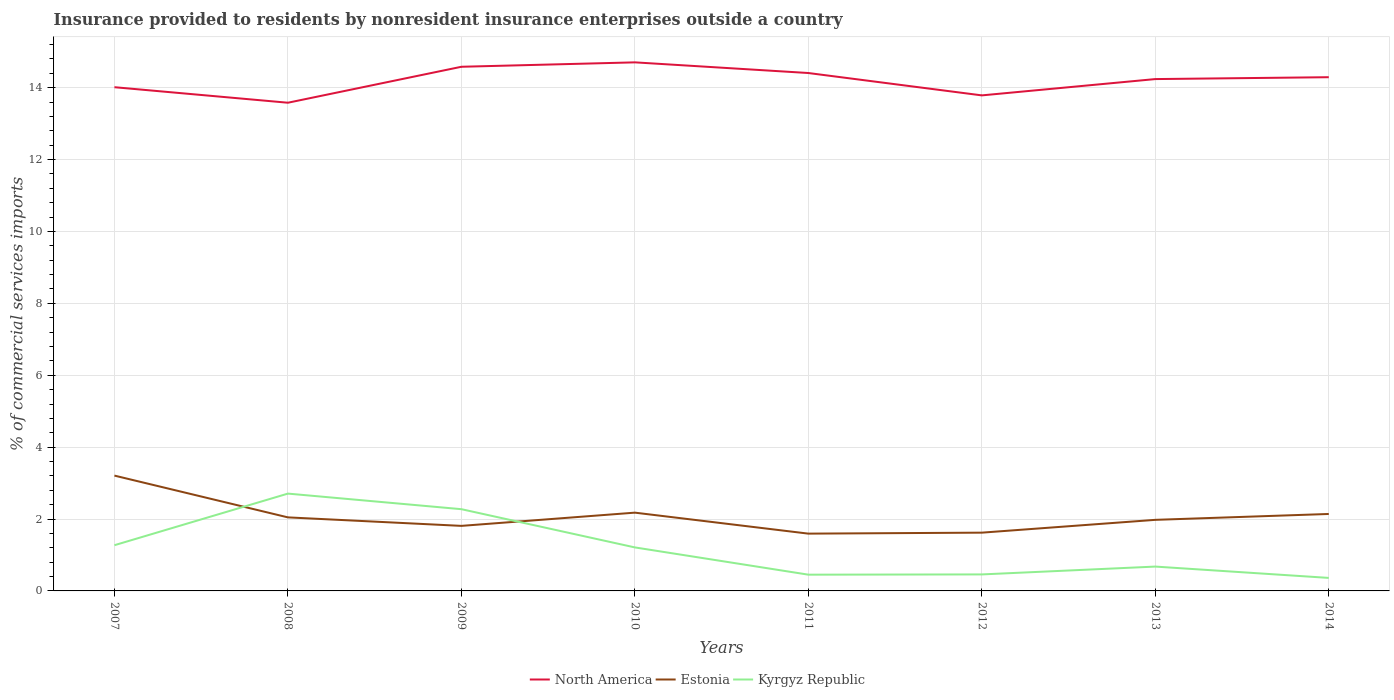Is the number of lines equal to the number of legend labels?
Your answer should be compact. Yes. Across all years, what is the maximum Insurance provided to residents in Estonia?
Provide a succinct answer. 1.59. What is the total Insurance provided to residents in North America in the graph?
Ensure brevity in your answer.  -0.12. What is the difference between the highest and the second highest Insurance provided to residents in North America?
Your answer should be compact. 1.12. Is the Insurance provided to residents in North America strictly greater than the Insurance provided to residents in Kyrgyz Republic over the years?
Offer a very short reply. No. How many years are there in the graph?
Give a very brief answer. 8. Does the graph contain any zero values?
Provide a short and direct response. No. How many legend labels are there?
Give a very brief answer. 3. How are the legend labels stacked?
Offer a very short reply. Horizontal. What is the title of the graph?
Make the answer very short. Insurance provided to residents by nonresident insurance enterprises outside a country. Does "Latin America(all income levels)" appear as one of the legend labels in the graph?
Give a very brief answer. No. What is the label or title of the Y-axis?
Provide a succinct answer. % of commercial services imports. What is the % of commercial services imports of North America in 2007?
Offer a very short reply. 14.01. What is the % of commercial services imports in Estonia in 2007?
Offer a very short reply. 3.21. What is the % of commercial services imports in Kyrgyz Republic in 2007?
Make the answer very short. 1.27. What is the % of commercial services imports of North America in 2008?
Provide a short and direct response. 13.58. What is the % of commercial services imports of Estonia in 2008?
Make the answer very short. 2.05. What is the % of commercial services imports of Kyrgyz Republic in 2008?
Offer a very short reply. 2.71. What is the % of commercial services imports in North America in 2009?
Your answer should be very brief. 14.58. What is the % of commercial services imports of Estonia in 2009?
Your answer should be very brief. 1.81. What is the % of commercial services imports in Kyrgyz Republic in 2009?
Make the answer very short. 2.27. What is the % of commercial services imports of North America in 2010?
Keep it short and to the point. 14.71. What is the % of commercial services imports in Estonia in 2010?
Keep it short and to the point. 2.18. What is the % of commercial services imports in Kyrgyz Republic in 2010?
Your answer should be very brief. 1.21. What is the % of commercial services imports of North America in 2011?
Provide a short and direct response. 14.41. What is the % of commercial services imports in Estonia in 2011?
Make the answer very short. 1.59. What is the % of commercial services imports of Kyrgyz Republic in 2011?
Keep it short and to the point. 0.45. What is the % of commercial services imports of North America in 2012?
Give a very brief answer. 13.79. What is the % of commercial services imports of Estonia in 2012?
Your answer should be very brief. 1.62. What is the % of commercial services imports of Kyrgyz Republic in 2012?
Provide a short and direct response. 0.46. What is the % of commercial services imports of North America in 2013?
Ensure brevity in your answer.  14.24. What is the % of commercial services imports of Estonia in 2013?
Offer a terse response. 1.98. What is the % of commercial services imports of Kyrgyz Republic in 2013?
Keep it short and to the point. 0.68. What is the % of commercial services imports in North America in 2014?
Ensure brevity in your answer.  14.29. What is the % of commercial services imports in Estonia in 2014?
Offer a very short reply. 2.14. What is the % of commercial services imports of Kyrgyz Republic in 2014?
Keep it short and to the point. 0.36. Across all years, what is the maximum % of commercial services imports in North America?
Give a very brief answer. 14.71. Across all years, what is the maximum % of commercial services imports of Estonia?
Provide a short and direct response. 3.21. Across all years, what is the maximum % of commercial services imports of Kyrgyz Republic?
Provide a succinct answer. 2.71. Across all years, what is the minimum % of commercial services imports of North America?
Keep it short and to the point. 13.58. Across all years, what is the minimum % of commercial services imports of Estonia?
Keep it short and to the point. 1.59. Across all years, what is the minimum % of commercial services imports of Kyrgyz Republic?
Give a very brief answer. 0.36. What is the total % of commercial services imports in North America in the graph?
Your response must be concise. 113.61. What is the total % of commercial services imports in Estonia in the graph?
Give a very brief answer. 16.57. What is the total % of commercial services imports in Kyrgyz Republic in the graph?
Give a very brief answer. 9.41. What is the difference between the % of commercial services imports of North America in 2007 and that in 2008?
Make the answer very short. 0.43. What is the difference between the % of commercial services imports in Estonia in 2007 and that in 2008?
Offer a very short reply. 1.16. What is the difference between the % of commercial services imports in Kyrgyz Republic in 2007 and that in 2008?
Offer a very short reply. -1.44. What is the difference between the % of commercial services imports of North America in 2007 and that in 2009?
Ensure brevity in your answer.  -0.57. What is the difference between the % of commercial services imports in Estonia in 2007 and that in 2009?
Ensure brevity in your answer.  1.4. What is the difference between the % of commercial services imports in Kyrgyz Republic in 2007 and that in 2009?
Provide a short and direct response. -1. What is the difference between the % of commercial services imports in North America in 2007 and that in 2010?
Your answer should be compact. -0.69. What is the difference between the % of commercial services imports of Estonia in 2007 and that in 2010?
Give a very brief answer. 1.03. What is the difference between the % of commercial services imports in Kyrgyz Republic in 2007 and that in 2010?
Provide a short and direct response. 0.06. What is the difference between the % of commercial services imports of North America in 2007 and that in 2011?
Your answer should be very brief. -0.39. What is the difference between the % of commercial services imports in Estonia in 2007 and that in 2011?
Give a very brief answer. 1.61. What is the difference between the % of commercial services imports in Kyrgyz Republic in 2007 and that in 2011?
Make the answer very short. 0.82. What is the difference between the % of commercial services imports of North America in 2007 and that in 2012?
Offer a very short reply. 0.23. What is the difference between the % of commercial services imports of Estonia in 2007 and that in 2012?
Provide a short and direct response. 1.59. What is the difference between the % of commercial services imports in Kyrgyz Republic in 2007 and that in 2012?
Ensure brevity in your answer.  0.81. What is the difference between the % of commercial services imports in North America in 2007 and that in 2013?
Your answer should be compact. -0.23. What is the difference between the % of commercial services imports in Estonia in 2007 and that in 2013?
Offer a very short reply. 1.23. What is the difference between the % of commercial services imports of Kyrgyz Republic in 2007 and that in 2013?
Your response must be concise. 0.59. What is the difference between the % of commercial services imports in North America in 2007 and that in 2014?
Keep it short and to the point. -0.28. What is the difference between the % of commercial services imports in Estonia in 2007 and that in 2014?
Provide a short and direct response. 1.07. What is the difference between the % of commercial services imports of Kyrgyz Republic in 2007 and that in 2014?
Offer a very short reply. 0.91. What is the difference between the % of commercial services imports of North America in 2008 and that in 2009?
Offer a terse response. -1. What is the difference between the % of commercial services imports in Estonia in 2008 and that in 2009?
Your answer should be compact. 0.24. What is the difference between the % of commercial services imports of Kyrgyz Republic in 2008 and that in 2009?
Make the answer very short. 0.43. What is the difference between the % of commercial services imports in North America in 2008 and that in 2010?
Ensure brevity in your answer.  -1.12. What is the difference between the % of commercial services imports in Estonia in 2008 and that in 2010?
Your response must be concise. -0.13. What is the difference between the % of commercial services imports in Kyrgyz Republic in 2008 and that in 2010?
Keep it short and to the point. 1.5. What is the difference between the % of commercial services imports in North America in 2008 and that in 2011?
Ensure brevity in your answer.  -0.83. What is the difference between the % of commercial services imports of Estonia in 2008 and that in 2011?
Ensure brevity in your answer.  0.45. What is the difference between the % of commercial services imports in Kyrgyz Republic in 2008 and that in 2011?
Offer a very short reply. 2.26. What is the difference between the % of commercial services imports of North America in 2008 and that in 2012?
Your response must be concise. -0.2. What is the difference between the % of commercial services imports of Estonia in 2008 and that in 2012?
Make the answer very short. 0.42. What is the difference between the % of commercial services imports of Kyrgyz Republic in 2008 and that in 2012?
Your answer should be very brief. 2.25. What is the difference between the % of commercial services imports of North America in 2008 and that in 2013?
Keep it short and to the point. -0.66. What is the difference between the % of commercial services imports in Estonia in 2008 and that in 2013?
Your answer should be very brief. 0.07. What is the difference between the % of commercial services imports of Kyrgyz Republic in 2008 and that in 2013?
Your response must be concise. 2.03. What is the difference between the % of commercial services imports in North America in 2008 and that in 2014?
Provide a succinct answer. -0.71. What is the difference between the % of commercial services imports of Estonia in 2008 and that in 2014?
Offer a very short reply. -0.09. What is the difference between the % of commercial services imports in Kyrgyz Republic in 2008 and that in 2014?
Provide a short and direct response. 2.35. What is the difference between the % of commercial services imports in North America in 2009 and that in 2010?
Provide a short and direct response. -0.12. What is the difference between the % of commercial services imports in Estonia in 2009 and that in 2010?
Provide a short and direct response. -0.37. What is the difference between the % of commercial services imports in Kyrgyz Republic in 2009 and that in 2010?
Your answer should be compact. 1.06. What is the difference between the % of commercial services imports in North America in 2009 and that in 2011?
Make the answer very short. 0.17. What is the difference between the % of commercial services imports in Estonia in 2009 and that in 2011?
Provide a succinct answer. 0.22. What is the difference between the % of commercial services imports of Kyrgyz Republic in 2009 and that in 2011?
Make the answer very short. 1.82. What is the difference between the % of commercial services imports in North America in 2009 and that in 2012?
Keep it short and to the point. 0.8. What is the difference between the % of commercial services imports of Estonia in 2009 and that in 2012?
Offer a very short reply. 0.19. What is the difference between the % of commercial services imports in Kyrgyz Republic in 2009 and that in 2012?
Your response must be concise. 1.81. What is the difference between the % of commercial services imports of North America in 2009 and that in 2013?
Ensure brevity in your answer.  0.34. What is the difference between the % of commercial services imports of Estonia in 2009 and that in 2013?
Your answer should be very brief. -0.17. What is the difference between the % of commercial services imports in Kyrgyz Republic in 2009 and that in 2013?
Your answer should be very brief. 1.6. What is the difference between the % of commercial services imports of North America in 2009 and that in 2014?
Offer a terse response. 0.29. What is the difference between the % of commercial services imports of Estonia in 2009 and that in 2014?
Your answer should be very brief. -0.33. What is the difference between the % of commercial services imports of Kyrgyz Republic in 2009 and that in 2014?
Your answer should be compact. 1.91. What is the difference between the % of commercial services imports in North America in 2010 and that in 2011?
Provide a succinct answer. 0.3. What is the difference between the % of commercial services imports of Estonia in 2010 and that in 2011?
Ensure brevity in your answer.  0.58. What is the difference between the % of commercial services imports of Kyrgyz Republic in 2010 and that in 2011?
Provide a succinct answer. 0.76. What is the difference between the % of commercial services imports of North America in 2010 and that in 2012?
Make the answer very short. 0.92. What is the difference between the % of commercial services imports of Estonia in 2010 and that in 2012?
Give a very brief answer. 0.56. What is the difference between the % of commercial services imports of Kyrgyz Republic in 2010 and that in 2012?
Offer a very short reply. 0.75. What is the difference between the % of commercial services imports in North America in 2010 and that in 2013?
Your answer should be compact. 0.47. What is the difference between the % of commercial services imports in Estonia in 2010 and that in 2013?
Your answer should be very brief. 0.2. What is the difference between the % of commercial services imports of Kyrgyz Republic in 2010 and that in 2013?
Provide a succinct answer. 0.53. What is the difference between the % of commercial services imports of North America in 2010 and that in 2014?
Make the answer very short. 0.41. What is the difference between the % of commercial services imports of Estonia in 2010 and that in 2014?
Ensure brevity in your answer.  0.04. What is the difference between the % of commercial services imports of Kyrgyz Republic in 2010 and that in 2014?
Your answer should be very brief. 0.85. What is the difference between the % of commercial services imports in North America in 2011 and that in 2012?
Provide a succinct answer. 0.62. What is the difference between the % of commercial services imports of Estonia in 2011 and that in 2012?
Your answer should be compact. -0.03. What is the difference between the % of commercial services imports in Kyrgyz Republic in 2011 and that in 2012?
Ensure brevity in your answer.  -0.01. What is the difference between the % of commercial services imports in North America in 2011 and that in 2013?
Keep it short and to the point. 0.17. What is the difference between the % of commercial services imports in Estonia in 2011 and that in 2013?
Ensure brevity in your answer.  -0.38. What is the difference between the % of commercial services imports in Kyrgyz Republic in 2011 and that in 2013?
Provide a short and direct response. -0.22. What is the difference between the % of commercial services imports in North America in 2011 and that in 2014?
Offer a terse response. 0.12. What is the difference between the % of commercial services imports in Estonia in 2011 and that in 2014?
Make the answer very short. -0.55. What is the difference between the % of commercial services imports in Kyrgyz Republic in 2011 and that in 2014?
Ensure brevity in your answer.  0.09. What is the difference between the % of commercial services imports in North America in 2012 and that in 2013?
Your answer should be compact. -0.45. What is the difference between the % of commercial services imports in Estonia in 2012 and that in 2013?
Make the answer very short. -0.36. What is the difference between the % of commercial services imports in Kyrgyz Republic in 2012 and that in 2013?
Your answer should be very brief. -0.22. What is the difference between the % of commercial services imports in North America in 2012 and that in 2014?
Offer a terse response. -0.51. What is the difference between the % of commercial services imports in Estonia in 2012 and that in 2014?
Ensure brevity in your answer.  -0.52. What is the difference between the % of commercial services imports of Kyrgyz Republic in 2012 and that in 2014?
Your answer should be very brief. 0.1. What is the difference between the % of commercial services imports in North America in 2013 and that in 2014?
Ensure brevity in your answer.  -0.05. What is the difference between the % of commercial services imports in Estonia in 2013 and that in 2014?
Offer a terse response. -0.16. What is the difference between the % of commercial services imports in Kyrgyz Republic in 2013 and that in 2014?
Keep it short and to the point. 0.32. What is the difference between the % of commercial services imports in North America in 2007 and the % of commercial services imports in Estonia in 2008?
Offer a very short reply. 11.97. What is the difference between the % of commercial services imports of North America in 2007 and the % of commercial services imports of Kyrgyz Republic in 2008?
Give a very brief answer. 11.31. What is the difference between the % of commercial services imports in Estonia in 2007 and the % of commercial services imports in Kyrgyz Republic in 2008?
Ensure brevity in your answer.  0.5. What is the difference between the % of commercial services imports of North America in 2007 and the % of commercial services imports of Estonia in 2009?
Give a very brief answer. 12.2. What is the difference between the % of commercial services imports in North America in 2007 and the % of commercial services imports in Kyrgyz Republic in 2009?
Your answer should be compact. 11.74. What is the difference between the % of commercial services imports in Estonia in 2007 and the % of commercial services imports in Kyrgyz Republic in 2009?
Keep it short and to the point. 0.93. What is the difference between the % of commercial services imports in North America in 2007 and the % of commercial services imports in Estonia in 2010?
Provide a succinct answer. 11.84. What is the difference between the % of commercial services imports of North America in 2007 and the % of commercial services imports of Kyrgyz Republic in 2010?
Make the answer very short. 12.8. What is the difference between the % of commercial services imports of Estonia in 2007 and the % of commercial services imports of Kyrgyz Republic in 2010?
Provide a succinct answer. 2. What is the difference between the % of commercial services imports in North America in 2007 and the % of commercial services imports in Estonia in 2011?
Keep it short and to the point. 12.42. What is the difference between the % of commercial services imports of North America in 2007 and the % of commercial services imports of Kyrgyz Republic in 2011?
Provide a short and direct response. 13.56. What is the difference between the % of commercial services imports of Estonia in 2007 and the % of commercial services imports of Kyrgyz Republic in 2011?
Provide a short and direct response. 2.76. What is the difference between the % of commercial services imports in North America in 2007 and the % of commercial services imports in Estonia in 2012?
Provide a short and direct response. 12.39. What is the difference between the % of commercial services imports of North America in 2007 and the % of commercial services imports of Kyrgyz Republic in 2012?
Provide a short and direct response. 13.55. What is the difference between the % of commercial services imports in Estonia in 2007 and the % of commercial services imports in Kyrgyz Republic in 2012?
Give a very brief answer. 2.75. What is the difference between the % of commercial services imports in North America in 2007 and the % of commercial services imports in Estonia in 2013?
Offer a terse response. 12.04. What is the difference between the % of commercial services imports of North America in 2007 and the % of commercial services imports of Kyrgyz Republic in 2013?
Your answer should be very brief. 13.34. What is the difference between the % of commercial services imports of Estonia in 2007 and the % of commercial services imports of Kyrgyz Republic in 2013?
Provide a succinct answer. 2.53. What is the difference between the % of commercial services imports in North America in 2007 and the % of commercial services imports in Estonia in 2014?
Make the answer very short. 11.87. What is the difference between the % of commercial services imports in North America in 2007 and the % of commercial services imports in Kyrgyz Republic in 2014?
Your answer should be compact. 13.65. What is the difference between the % of commercial services imports of Estonia in 2007 and the % of commercial services imports of Kyrgyz Republic in 2014?
Your answer should be compact. 2.85. What is the difference between the % of commercial services imports in North America in 2008 and the % of commercial services imports in Estonia in 2009?
Your answer should be very brief. 11.77. What is the difference between the % of commercial services imports in North America in 2008 and the % of commercial services imports in Kyrgyz Republic in 2009?
Offer a terse response. 11.31. What is the difference between the % of commercial services imports of Estonia in 2008 and the % of commercial services imports of Kyrgyz Republic in 2009?
Your response must be concise. -0.23. What is the difference between the % of commercial services imports in North America in 2008 and the % of commercial services imports in Estonia in 2010?
Provide a short and direct response. 11.4. What is the difference between the % of commercial services imports of North America in 2008 and the % of commercial services imports of Kyrgyz Republic in 2010?
Your response must be concise. 12.37. What is the difference between the % of commercial services imports of Estonia in 2008 and the % of commercial services imports of Kyrgyz Republic in 2010?
Offer a terse response. 0.84. What is the difference between the % of commercial services imports in North America in 2008 and the % of commercial services imports in Estonia in 2011?
Provide a succinct answer. 11.99. What is the difference between the % of commercial services imports in North America in 2008 and the % of commercial services imports in Kyrgyz Republic in 2011?
Provide a succinct answer. 13.13. What is the difference between the % of commercial services imports of Estonia in 2008 and the % of commercial services imports of Kyrgyz Republic in 2011?
Your answer should be compact. 1.59. What is the difference between the % of commercial services imports of North America in 2008 and the % of commercial services imports of Estonia in 2012?
Your response must be concise. 11.96. What is the difference between the % of commercial services imports in North America in 2008 and the % of commercial services imports in Kyrgyz Republic in 2012?
Ensure brevity in your answer.  13.12. What is the difference between the % of commercial services imports in Estonia in 2008 and the % of commercial services imports in Kyrgyz Republic in 2012?
Your answer should be very brief. 1.59. What is the difference between the % of commercial services imports of North America in 2008 and the % of commercial services imports of Estonia in 2013?
Your answer should be very brief. 11.6. What is the difference between the % of commercial services imports in North America in 2008 and the % of commercial services imports in Kyrgyz Republic in 2013?
Provide a succinct answer. 12.9. What is the difference between the % of commercial services imports in Estonia in 2008 and the % of commercial services imports in Kyrgyz Republic in 2013?
Your response must be concise. 1.37. What is the difference between the % of commercial services imports in North America in 2008 and the % of commercial services imports in Estonia in 2014?
Your answer should be very brief. 11.44. What is the difference between the % of commercial services imports in North America in 2008 and the % of commercial services imports in Kyrgyz Republic in 2014?
Offer a very short reply. 13.22. What is the difference between the % of commercial services imports of Estonia in 2008 and the % of commercial services imports of Kyrgyz Republic in 2014?
Offer a terse response. 1.68. What is the difference between the % of commercial services imports of North America in 2009 and the % of commercial services imports of Estonia in 2010?
Your answer should be compact. 12.4. What is the difference between the % of commercial services imports of North America in 2009 and the % of commercial services imports of Kyrgyz Republic in 2010?
Provide a succinct answer. 13.37. What is the difference between the % of commercial services imports of Estonia in 2009 and the % of commercial services imports of Kyrgyz Republic in 2010?
Provide a short and direct response. 0.6. What is the difference between the % of commercial services imports in North America in 2009 and the % of commercial services imports in Estonia in 2011?
Ensure brevity in your answer.  12.99. What is the difference between the % of commercial services imports of North America in 2009 and the % of commercial services imports of Kyrgyz Republic in 2011?
Your answer should be very brief. 14.13. What is the difference between the % of commercial services imports in Estonia in 2009 and the % of commercial services imports in Kyrgyz Republic in 2011?
Offer a very short reply. 1.36. What is the difference between the % of commercial services imports in North America in 2009 and the % of commercial services imports in Estonia in 2012?
Your answer should be very brief. 12.96. What is the difference between the % of commercial services imports in North America in 2009 and the % of commercial services imports in Kyrgyz Republic in 2012?
Offer a terse response. 14.12. What is the difference between the % of commercial services imports of Estonia in 2009 and the % of commercial services imports of Kyrgyz Republic in 2012?
Make the answer very short. 1.35. What is the difference between the % of commercial services imports of North America in 2009 and the % of commercial services imports of Estonia in 2013?
Keep it short and to the point. 12.6. What is the difference between the % of commercial services imports of North America in 2009 and the % of commercial services imports of Kyrgyz Republic in 2013?
Your answer should be compact. 13.91. What is the difference between the % of commercial services imports in Estonia in 2009 and the % of commercial services imports in Kyrgyz Republic in 2013?
Ensure brevity in your answer.  1.13. What is the difference between the % of commercial services imports of North America in 2009 and the % of commercial services imports of Estonia in 2014?
Your answer should be compact. 12.44. What is the difference between the % of commercial services imports of North America in 2009 and the % of commercial services imports of Kyrgyz Republic in 2014?
Your answer should be very brief. 14.22. What is the difference between the % of commercial services imports of Estonia in 2009 and the % of commercial services imports of Kyrgyz Republic in 2014?
Provide a short and direct response. 1.45. What is the difference between the % of commercial services imports in North America in 2010 and the % of commercial services imports in Estonia in 2011?
Your answer should be compact. 13.11. What is the difference between the % of commercial services imports in North America in 2010 and the % of commercial services imports in Kyrgyz Republic in 2011?
Provide a short and direct response. 14.25. What is the difference between the % of commercial services imports in Estonia in 2010 and the % of commercial services imports in Kyrgyz Republic in 2011?
Your answer should be compact. 1.73. What is the difference between the % of commercial services imports of North America in 2010 and the % of commercial services imports of Estonia in 2012?
Your response must be concise. 13.08. What is the difference between the % of commercial services imports of North America in 2010 and the % of commercial services imports of Kyrgyz Republic in 2012?
Give a very brief answer. 14.25. What is the difference between the % of commercial services imports in Estonia in 2010 and the % of commercial services imports in Kyrgyz Republic in 2012?
Provide a short and direct response. 1.72. What is the difference between the % of commercial services imports in North America in 2010 and the % of commercial services imports in Estonia in 2013?
Your response must be concise. 12.73. What is the difference between the % of commercial services imports in North America in 2010 and the % of commercial services imports in Kyrgyz Republic in 2013?
Provide a succinct answer. 14.03. What is the difference between the % of commercial services imports of Estonia in 2010 and the % of commercial services imports of Kyrgyz Republic in 2013?
Your answer should be very brief. 1.5. What is the difference between the % of commercial services imports in North America in 2010 and the % of commercial services imports in Estonia in 2014?
Your answer should be very brief. 12.56. What is the difference between the % of commercial services imports of North America in 2010 and the % of commercial services imports of Kyrgyz Republic in 2014?
Offer a very short reply. 14.34. What is the difference between the % of commercial services imports of Estonia in 2010 and the % of commercial services imports of Kyrgyz Republic in 2014?
Provide a short and direct response. 1.82. What is the difference between the % of commercial services imports of North America in 2011 and the % of commercial services imports of Estonia in 2012?
Your answer should be very brief. 12.79. What is the difference between the % of commercial services imports in North America in 2011 and the % of commercial services imports in Kyrgyz Republic in 2012?
Offer a very short reply. 13.95. What is the difference between the % of commercial services imports in Estonia in 2011 and the % of commercial services imports in Kyrgyz Republic in 2012?
Your answer should be very brief. 1.13. What is the difference between the % of commercial services imports of North America in 2011 and the % of commercial services imports of Estonia in 2013?
Keep it short and to the point. 12.43. What is the difference between the % of commercial services imports in North America in 2011 and the % of commercial services imports in Kyrgyz Republic in 2013?
Ensure brevity in your answer.  13.73. What is the difference between the % of commercial services imports of Estonia in 2011 and the % of commercial services imports of Kyrgyz Republic in 2013?
Your answer should be very brief. 0.92. What is the difference between the % of commercial services imports of North America in 2011 and the % of commercial services imports of Estonia in 2014?
Your answer should be compact. 12.27. What is the difference between the % of commercial services imports of North America in 2011 and the % of commercial services imports of Kyrgyz Republic in 2014?
Provide a short and direct response. 14.05. What is the difference between the % of commercial services imports of Estonia in 2011 and the % of commercial services imports of Kyrgyz Republic in 2014?
Your answer should be very brief. 1.23. What is the difference between the % of commercial services imports of North America in 2012 and the % of commercial services imports of Estonia in 2013?
Your answer should be compact. 11.81. What is the difference between the % of commercial services imports of North America in 2012 and the % of commercial services imports of Kyrgyz Republic in 2013?
Your answer should be compact. 13.11. What is the difference between the % of commercial services imports of Estonia in 2012 and the % of commercial services imports of Kyrgyz Republic in 2013?
Give a very brief answer. 0.94. What is the difference between the % of commercial services imports in North America in 2012 and the % of commercial services imports in Estonia in 2014?
Ensure brevity in your answer.  11.65. What is the difference between the % of commercial services imports in North America in 2012 and the % of commercial services imports in Kyrgyz Republic in 2014?
Give a very brief answer. 13.42. What is the difference between the % of commercial services imports in Estonia in 2012 and the % of commercial services imports in Kyrgyz Republic in 2014?
Make the answer very short. 1.26. What is the difference between the % of commercial services imports in North America in 2013 and the % of commercial services imports in Estonia in 2014?
Your answer should be very brief. 12.1. What is the difference between the % of commercial services imports in North America in 2013 and the % of commercial services imports in Kyrgyz Republic in 2014?
Offer a very short reply. 13.88. What is the difference between the % of commercial services imports of Estonia in 2013 and the % of commercial services imports of Kyrgyz Republic in 2014?
Your response must be concise. 1.62. What is the average % of commercial services imports of North America per year?
Provide a short and direct response. 14.2. What is the average % of commercial services imports in Estonia per year?
Provide a succinct answer. 2.07. What is the average % of commercial services imports of Kyrgyz Republic per year?
Your answer should be very brief. 1.18. In the year 2007, what is the difference between the % of commercial services imports of North America and % of commercial services imports of Estonia?
Give a very brief answer. 10.81. In the year 2007, what is the difference between the % of commercial services imports of North America and % of commercial services imports of Kyrgyz Republic?
Ensure brevity in your answer.  12.74. In the year 2007, what is the difference between the % of commercial services imports in Estonia and % of commercial services imports in Kyrgyz Republic?
Make the answer very short. 1.94. In the year 2008, what is the difference between the % of commercial services imports of North America and % of commercial services imports of Estonia?
Your response must be concise. 11.54. In the year 2008, what is the difference between the % of commercial services imports of North America and % of commercial services imports of Kyrgyz Republic?
Provide a short and direct response. 10.87. In the year 2008, what is the difference between the % of commercial services imports in Estonia and % of commercial services imports in Kyrgyz Republic?
Ensure brevity in your answer.  -0.66. In the year 2009, what is the difference between the % of commercial services imports of North America and % of commercial services imports of Estonia?
Give a very brief answer. 12.77. In the year 2009, what is the difference between the % of commercial services imports in North America and % of commercial services imports in Kyrgyz Republic?
Your response must be concise. 12.31. In the year 2009, what is the difference between the % of commercial services imports in Estonia and % of commercial services imports in Kyrgyz Republic?
Your answer should be very brief. -0.46. In the year 2010, what is the difference between the % of commercial services imports of North America and % of commercial services imports of Estonia?
Provide a short and direct response. 12.53. In the year 2010, what is the difference between the % of commercial services imports of North America and % of commercial services imports of Kyrgyz Republic?
Give a very brief answer. 13.49. In the year 2010, what is the difference between the % of commercial services imports of Estonia and % of commercial services imports of Kyrgyz Republic?
Provide a short and direct response. 0.97. In the year 2011, what is the difference between the % of commercial services imports in North America and % of commercial services imports in Estonia?
Keep it short and to the point. 12.81. In the year 2011, what is the difference between the % of commercial services imports in North America and % of commercial services imports in Kyrgyz Republic?
Give a very brief answer. 13.96. In the year 2011, what is the difference between the % of commercial services imports of Estonia and % of commercial services imports of Kyrgyz Republic?
Make the answer very short. 1.14. In the year 2012, what is the difference between the % of commercial services imports in North America and % of commercial services imports in Estonia?
Provide a succinct answer. 12.17. In the year 2012, what is the difference between the % of commercial services imports in North America and % of commercial services imports in Kyrgyz Republic?
Offer a terse response. 13.33. In the year 2012, what is the difference between the % of commercial services imports of Estonia and % of commercial services imports of Kyrgyz Republic?
Make the answer very short. 1.16. In the year 2013, what is the difference between the % of commercial services imports in North America and % of commercial services imports in Estonia?
Provide a short and direct response. 12.26. In the year 2013, what is the difference between the % of commercial services imports in North America and % of commercial services imports in Kyrgyz Republic?
Keep it short and to the point. 13.56. In the year 2013, what is the difference between the % of commercial services imports in Estonia and % of commercial services imports in Kyrgyz Republic?
Your answer should be compact. 1.3. In the year 2014, what is the difference between the % of commercial services imports of North America and % of commercial services imports of Estonia?
Make the answer very short. 12.15. In the year 2014, what is the difference between the % of commercial services imports of North America and % of commercial services imports of Kyrgyz Republic?
Make the answer very short. 13.93. In the year 2014, what is the difference between the % of commercial services imports of Estonia and % of commercial services imports of Kyrgyz Republic?
Your answer should be very brief. 1.78. What is the ratio of the % of commercial services imports of North America in 2007 to that in 2008?
Offer a very short reply. 1.03. What is the ratio of the % of commercial services imports of Estonia in 2007 to that in 2008?
Keep it short and to the point. 1.57. What is the ratio of the % of commercial services imports in Kyrgyz Republic in 2007 to that in 2008?
Keep it short and to the point. 0.47. What is the ratio of the % of commercial services imports in Estonia in 2007 to that in 2009?
Provide a succinct answer. 1.77. What is the ratio of the % of commercial services imports of Kyrgyz Republic in 2007 to that in 2009?
Your answer should be very brief. 0.56. What is the ratio of the % of commercial services imports of North America in 2007 to that in 2010?
Offer a terse response. 0.95. What is the ratio of the % of commercial services imports of Estonia in 2007 to that in 2010?
Your answer should be very brief. 1.47. What is the ratio of the % of commercial services imports in Kyrgyz Republic in 2007 to that in 2010?
Your answer should be compact. 1.05. What is the ratio of the % of commercial services imports in North America in 2007 to that in 2011?
Provide a succinct answer. 0.97. What is the ratio of the % of commercial services imports of Estonia in 2007 to that in 2011?
Provide a succinct answer. 2.01. What is the ratio of the % of commercial services imports of Kyrgyz Republic in 2007 to that in 2011?
Offer a very short reply. 2.81. What is the ratio of the % of commercial services imports in North America in 2007 to that in 2012?
Give a very brief answer. 1.02. What is the ratio of the % of commercial services imports of Estonia in 2007 to that in 2012?
Keep it short and to the point. 1.98. What is the ratio of the % of commercial services imports of Kyrgyz Republic in 2007 to that in 2012?
Provide a succinct answer. 2.77. What is the ratio of the % of commercial services imports in North America in 2007 to that in 2013?
Provide a succinct answer. 0.98. What is the ratio of the % of commercial services imports of Estonia in 2007 to that in 2013?
Offer a terse response. 1.62. What is the ratio of the % of commercial services imports in Kyrgyz Republic in 2007 to that in 2013?
Your answer should be very brief. 1.88. What is the ratio of the % of commercial services imports in North America in 2007 to that in 2014?
Your answer should be very brief. 0.98. What is the ratio of the % of commercial services imports in Estonia in 2007 to that in 2014?
Offer a very short reply. 1.5. What is the ratio of the % of commercial services imports of Kyrgyz Republic in 2007 to that in 2014?
Offer a very short reply. 3.51. What is the ratio of the % of commercial services imports in North America in 2008 to that in 2009?
Offer a terse response. 0.93. What is the ratio of the % of commercial services imports in Estonia in 2008 to that in 2009?
Keep it short and to the point. 1.13. What is the ratio of the % of commercial services imports in Kyrgyz Republic in 2008 to that in 2009?
Provide a succinct answer. 1.19. What is the ratio of the % of commercial services imports of North America in 2008 to that in 2010?
Make the answer very short. 0.92. What is the ratio of the % of commercial services imports in Estonia in 2008 to that in 2010?
Give a very brief answer. 0.94. What is the ratio of the % of commercial services imports of Kyrgyz Republic in 2008 to that in 2010?
Offer a terse response. 2.24. What is the ratio of the % of commercial services imports of North America in 2008 to that in 2011?
Offer a terse response. 0.94. What is the ratio of the % of commercial services imports of Estonia in 2008 to that in 2011?
Offer a terse response. 1.28. What is the ratio of the % of commercial services imports in Kyrgyz Republic in 2008 to that in 2011?
Provide a succinct answer. 5.99. What is the ratio of the % of commercial services imports of North America in 2008 to that in 2012?
Your answer should be very brief. 0.99. What is the ratio of the % of commercial services imports in Estonia in 2008 to that in 2012?
Provide a short and direct response. 1.26. What is the ratio of the % of commercial services imports in Kyrgyz Republic in 2008 to that in 2012?
Offer a terse response. 5.9. What is the ratio of the % of commercial services imports in North America in 2008 to that in 2013?
Keep it short and to the point. 0.95. What is the ratio of the % of commercial services imports in Estonia in 2008 to that in 2013?
Offer a very short reply. 1.03. What is the ratio of the % of commercial services imports in Kyrgyz Republic in 2008 to that in 2013?
Offer a very short reply. 4. What is the ratio of the % of commercial services imports of North America in 2008 to that in 2014?
Your answer should be compact. 0.95. What is the ratio of the % of commercial services imports of Estonia in 2008 to that in 2014?
Ensure brevity in your answer.  0.96. What is the ratio of the % of commercial services imports of Kyrgyz Republic in 2008 to that in 2014?
Keep it short and to the point. 7.48. What is the ratio of the % of commercial services imports of Estonia in 2009 to that in 2010?
Provide a short and direct response. 0.83. What is the ratio of the % of commercial services imports of Kyrgyz Republic in 2009 to that in 2010?
Your response must be concise. 1.88. What is the ratio of the % of commercial services imports of North America in 2009 to that in 2011?
Ensure brevity in your answer.  1.01. What is the ratio of the % of commercial services imports of Estonia in 2009 to that in 2011?
Make the answer very short. 1.14. What is the ratio of the % of commercial services imports of Kyrgyz Republic in 2009 to that in 2011?
Provide a short and direct response. 5.03. What is the ratio of the % of commercial services imports in North America in 2009 to that in 2012?
Your answer should be compact. 1.06. What is the ratio of the % of commercial services imports of Estonia in 2009 to that in 2012?
Offer a terse response. 1.12. What is the ratio of the % of commercial services imports in Kyrgyz Republic in 2009 to that in 2012?
Your response must be concise. 4.95. What is the ratio of the % of commercial services imports of North America in 2009 to that in 2013?
Provide a short and direct response. 1.02. What is the ratio of the % of commercial services imports in Estonia in 2009 to that in 2013?
Ensure brevity in your answer.  0.92. What is the ratio of the % of commercial services imports of Kyrgyz Republic in 2009 to that in 2013?
Offer a terse response. 3.36. What is the ratio of the % of commercial services imports in North America in 2009 to that in 2014?
Ensure brevity in your answer.  1.02. What is the ratio of the % of commercial services imports in Estonia in 2009 to that in 2014?
Your answer should be very brief. 0.85. What is the ratio of the % of commercial services imports of Kyrgyz Republic in 2009 to that in 2014?
Keep it short and to the point. 6.28. What is the ratio of the % of commercial services imports of North America in 2010 to that in 2011?
Your answer should be very brief. 1.02. What is the ratio of the % of commercial services imports in Estonia in 2010 to that in 2011?
Ensure brevity in your answer.  1.37. What is the ratio of the % of commercial services imports in Kyrgyz Republic in 2010 to that in 2011?
Make the answer very short. 2.68. What is the ratio of the % of commercial services imports of North America in 2010 to that in 2012?
Your response must be concise. 1.07. What is the ratio of the % of commercial services imports of Estonia in 2010 to that in 2012?
Offer a terse response. 1.34. What is the ratio of the % of commercial services imports of Kyrgyz Republic in 2010 to that in 2012?
Your answer should be compact. 2.64. What is the ratio of the % of commercial services imports in North America in 2010 to that in 2013?
Keep it short and to the point. 1.03. What is the ratio of the % of commercial services imports in Estonia in 2010 to that in 2013?
Provide a succinct answer. 1.1. What is the ratio of the % of commercial services imports in Kyrgyz Republic in 2010 to that in 2013?
Your response must be concise. 1.79. What is the ratio of the % of commercial services imports of North America in 2010 to that in 2014?
Make the answer very short. 1.03. What is the ratio of the % of commercial services imports in Estonia in 2010 to that in 2014?
Give a very brief answer. 1.02. What is the ratio of the % of commercial services imports of Kyrgyz Republic in 2010 to that in 2014?
Give a very brief answer. 3.34. What is the ratio of the % of commercial services imports of North America in 2011 to that in 2012?
Provide a succinct answer. 1.05. What is the ratio of the % of commercial services imports in Estonia in 2011 to that in 2012?
Ensure brevity in your answer.  0.98. What is the ratio of the % of commercial services imports in Kyrgyz Republic in 2011 to that in 2012?
Your answer should be compact. 0.99. What is the ratio of the % of commercial services imports in North America in 2011 to that in 2013?
Offer a very short reply. 1.01. What is the ratio of the % of commercial services imports in Estonia in 2011 to that in 2013?
Make the answer very short. 0.81. What is the ratio of the % of commercial services imports in Kyrgyz Republic in 2011 to that in 2013?
Offer a terse response. 0.67. What is the ratio of the % of commercial services imports in Estonia in 2011 to that in 2014?
Your answer should be very brief. 0.74. What is the ratio of the % of commercial services imports in Kyrgyz Republic in 2011 to that in 2014?
Ensure brevity in your answer.  1.25. What is the ratio of the % of commercial services imports in North America in 2012 to that in 2013?
Keep it short and to the point. 0.97. What is the ratio of the % of commercial services imports in Estonia in 2012 to that in 2013?
Ensure brevity in your answer.  0.82. What is the ratio of the % of commercial services imports in Kyrgyz Republic in 2012 to that in 2013?
Provide a short and direct response. 0.68. What is the ratio of the % of commercial services imports in North America in 2012 to that in 2014?
Your answer should be compact. 0.96. What is the ratio of the % of commercial services imports of Estonia in 2012 to that in 2014?
Provide a short and direct response. 0.76. What is the ratio of the % of commercial services imports of Kyrgyz Republic in 2012 to that in 2014?
Your answer should be compact. 1.27. What is the ratio of the % of commercial services imports of North America in 2013 to that in 2014?
Your answer should be very brief. 1. What is the ratio of the % of commercial services imports of Estonia in 2013 to that in 2014?
Give a very brief answer. 0.92. What is the ratio of the % of commercial services imports in Kyrgyz Republic in 2013 to that in 2014?
Ensure brevity in your answer.  1.87. What is the difference between the highest and the second highest % of commercial services imports of North America?
Ensure brevity in your answer.  0.12. What is the difference between the highest and the second highest % of commercial services imports of Estonia?
Your response must be concise. 1.03. What is the difference between the highest and the second highest % of commercial services imports of Kyrgyz Republic?
Ensure brevity in your answer.  0.43. What is the difference between the highest and the lowest % of commercial services imports in North America?
Provide a succinct answer. 1.12. What is the difference between the highest and the lowest % of commercial services imports in Estonia?
Ensure brevity in your answer.  1.61. What is the difference between the highest and the lowest % of commercial services imports of Kyrgyz Republic?
Provide a short and direct response. 2.35. 